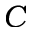Convert formula to latex. <formula><loc_0><loc_0><loc_500><loc_500>C</formula> 